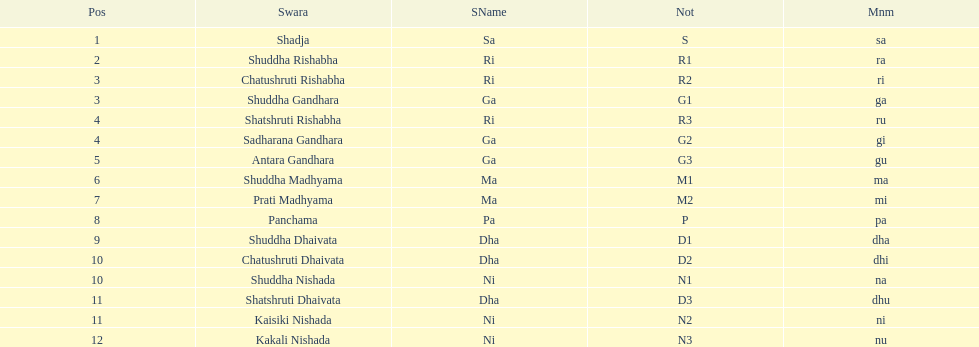Which swara holds the last position? Kakali Nishada. Could you help me parse every detail presented in this table? {'header': ['Pos', 'Swara', 'SName', 'Not', 'Mnm'], 'rows': [['1', 'Shadja', 'Sa', 'S', 'sa'], ['2', 'Shuddha Rishabha', 'Ri', 'R1', 'ra'], ['3', 'Chatushruti Rishabha', 'Ri', 'R2', 'ri'], ['3', 'Shuddha Gandhara', 'Ga', 'G1', 'ga'], ['4', 'Shatshruti Rishabha', 'Ri', 'R3', 'ru'], ['4', 'Sadharana Gandhara', 'Ga', 'G2', 'gi'], ['5', 'Antara Gandhara', 'Ga', 'G3', 'gu'], ['6', 'Shuddha Madhyama', 'Ma', 'M1', 'ma'], ['7', 'Prati Madhyama', 'Ma', 'M2', 'mi'], ['8', 'Panchama', 'Pa', 'P', 'pa'], ['9', 'Shuddha Dhaivata', 'Dha', 'D1', 'dha'], ['10', 'Chatushruti Dhaivata', 'Dha', 'D2', 'dhi'], ['10', 'Shuddha Nishada', 'Ni', 'N1', 'na'], ['11', 'Shatshruti Dhaivata', 'Dha', 'D3', 'dhu'], ['11', 'Kaisiki Nishada', 'Ni', 'N2', 'ni'], ['12', 'Kakali Nishada', 'Ni', 'N3', 'nu']]} 